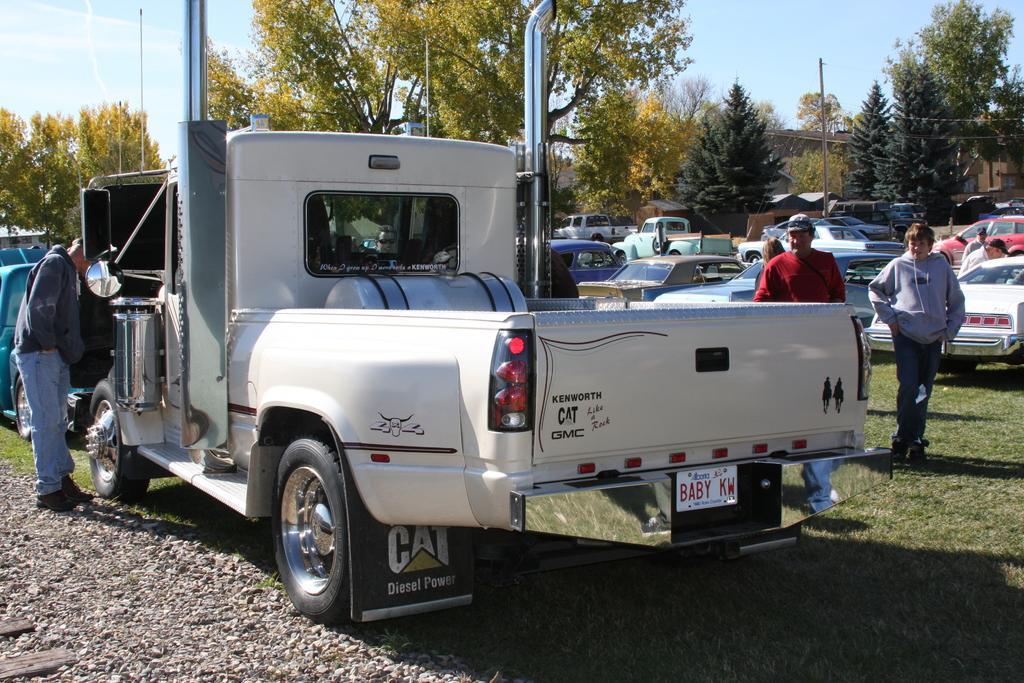How would you summarize this image in a sentence or two? This is an outside view. Here I can see a truck on the ground. Beside the truck there is a man standing. On the right side, I can see some more people standing on the ground. In the background there are many vehicles and trees. At the top of the image I can see the sky. At the bottom, I can see the stones and grass on the ground. In the background there are few buildings. 